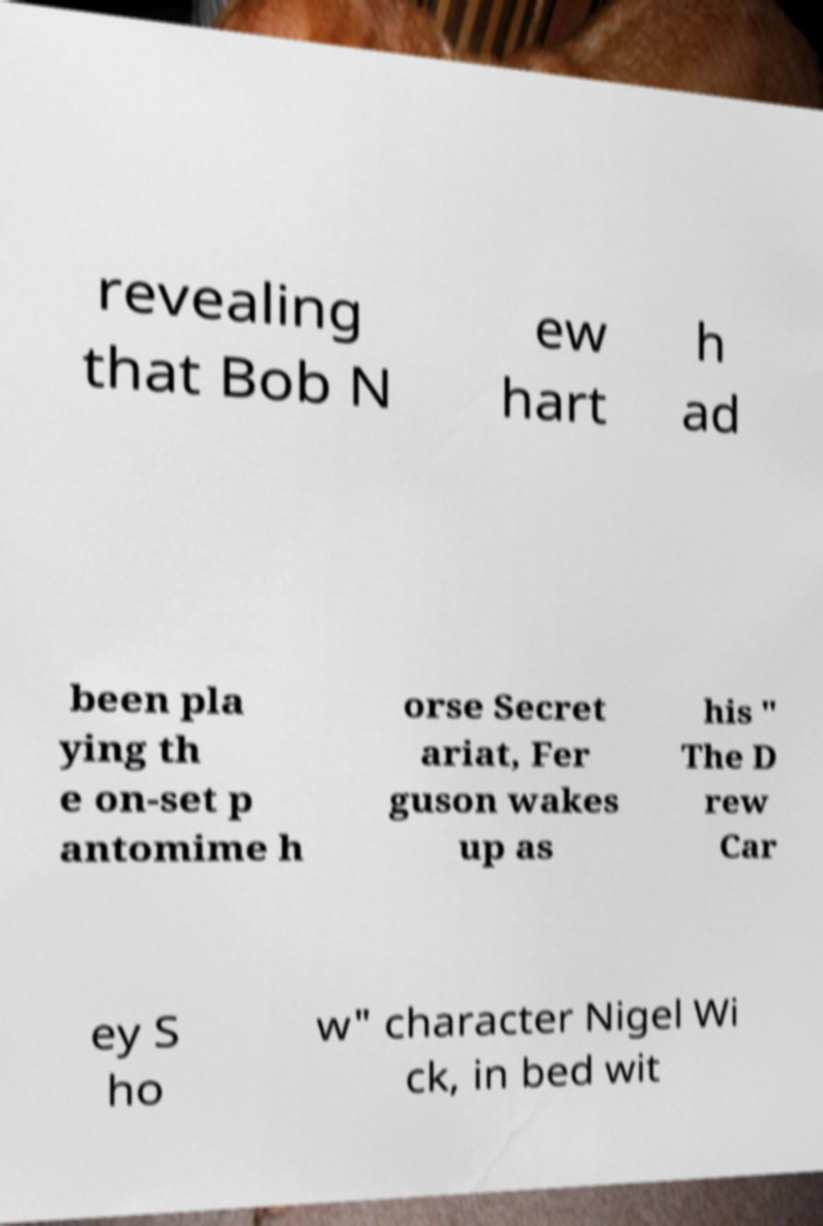There's text embedded in this image that I need extracted. Can you transcribe it verbatim? revealing that Bob N ew hart h ad been pla ying th e on-set p antomime h orse Secret ariat, Fer guson wakes up as his " The D rew Car ey S ho w" character Nigel Wi ck, in bed wit 